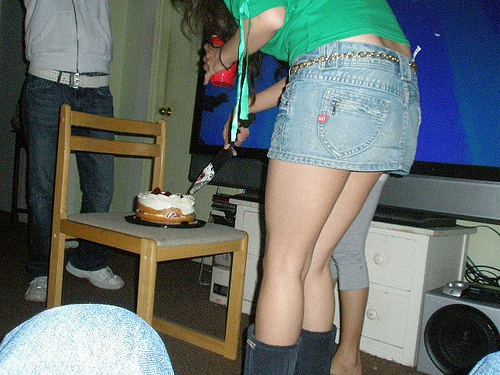Describe the objects in this image and their specific colors. I can see people in teal, tan, darkgray, lightblue, and black tones, people in teal, black, darkgray, gray, and olive tones, chair in teal, black, olive, tan, and gray tones, tv in teal, navy, darkblue, blue, and black tones, and people in teal, darkgray, and gray tones in this image. 